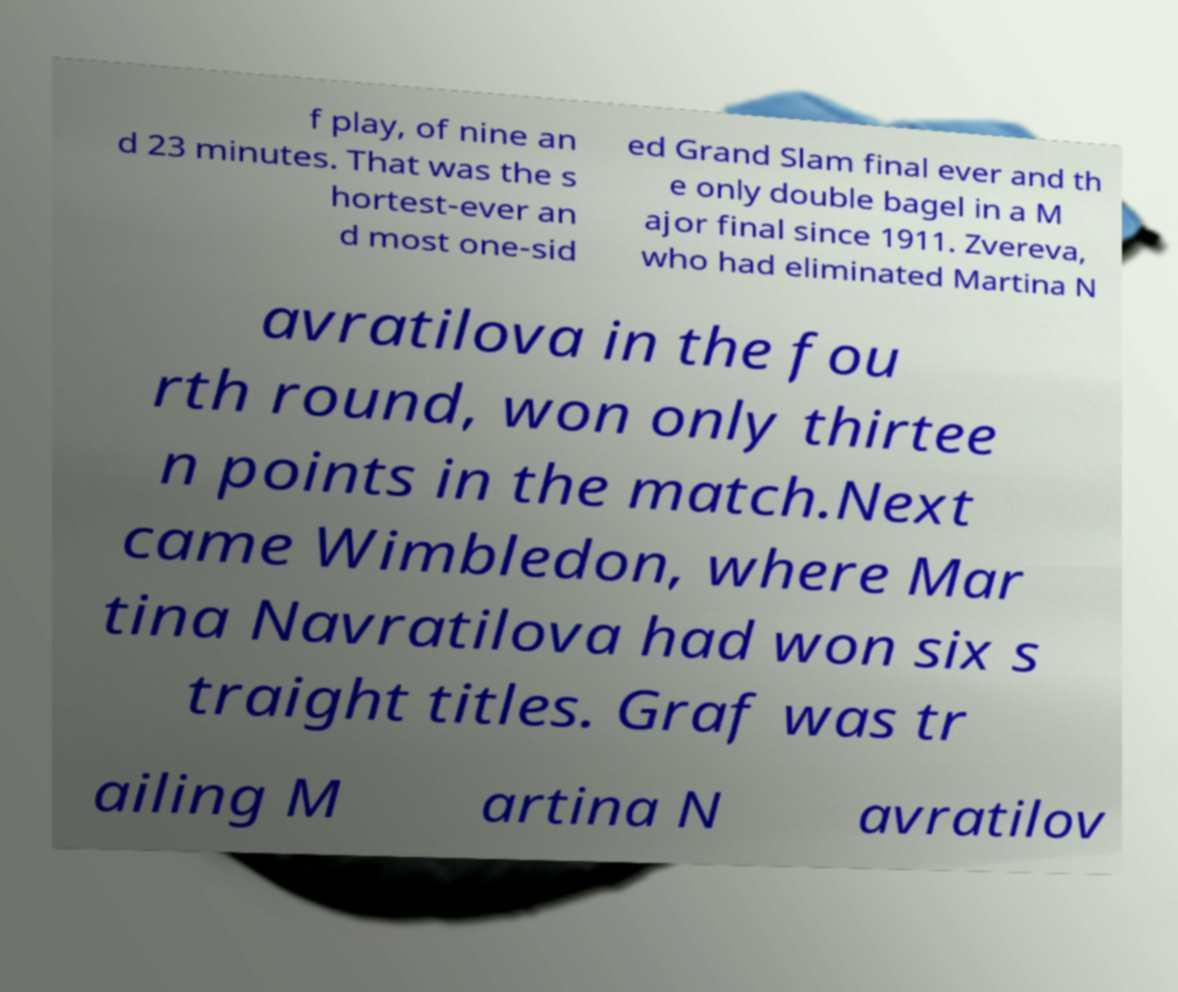What messages or text are displayed in this image? I need them in a readable, typed format. f play, of nine an d 23 minutes. That was the s hortest-ever an d most one-sid ed Grand Slam final ever and th e only double bagel in a M ajor final since 1911. Zvereva, who had eliminated Martina N avratilova in the fou rth round, won only thirtee n points in the match.Next came Wimbledon, where Mar tina Navratilova had won six s traight titles. Graf was tr ailing M artina N avratilov 